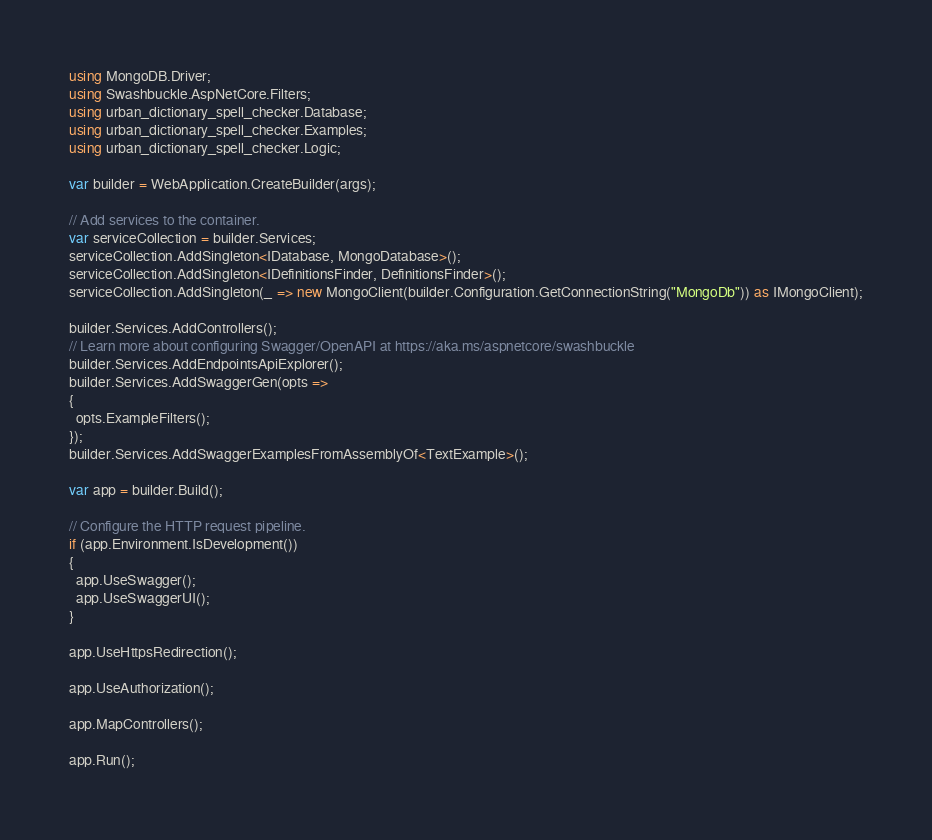Convert code to text. <code><loc_0><loc_0><loc_500><loc_500><_C#_>using MongoDB.Driver;
using Swashbuckle.AspNetCore.Filters;
using urban_dictionary_spell_checker.Database;
using urban_dictionary_spell_checker.Examples;
using urban_dictionary_spell_checker.Logic;

var builder = WebApplication.CreateBuilder(args);

// Add services to the container.
var serviceCollection = builder.Services;
serviceCollection.AddSingleton<IDatabase, MongoDatabase>();
serviceCollection.AddSingleton<IDefinitionsFinder, DefinitionsFinder>();
serviceCollection.AddSingleton(_ => new MongoClient(builder.Configuration.GetConnectionString("MongoDb")) as IMongoClient);

builder.Services.AddControllers();
// Learn more about configuring Swagger/OpenAPI at https://aka.ms/aspnetcore/swashbuckle
builder.Services.AddEndpointsApiExplorer();
builder.Services.AddSwaggerGen(opts =>
{
  opts.ExampleFilters();
});
builder.Services.AddSwaggerExamplesFromAssemblyOf<TextExample>();

var app = builder.Build();

// Configure the HTTP request pipeline.
if (app.Environment.IsDevelopment())
{
  app.UseSwagger();
  app.UseSwaggerUI();
}

app.UseHttpsRedirection();

app.UseAuthorization();

app.MapControllers();

app.Run();
</code> 